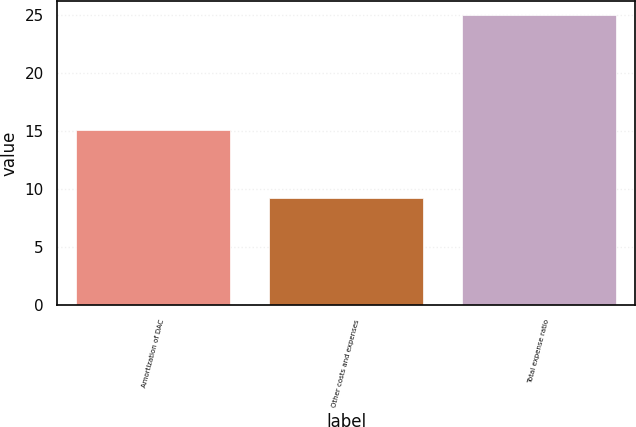Convert chart. <chart><loc_0><loc_0><loc_500><loc_500><bar_chart><fcel>Amortization of DAC<fcel>Other costs and expenses<fcel>Total expense ratio<nl><fcel>15.1<fcel>9.3<fcel>25<nl></chart> 